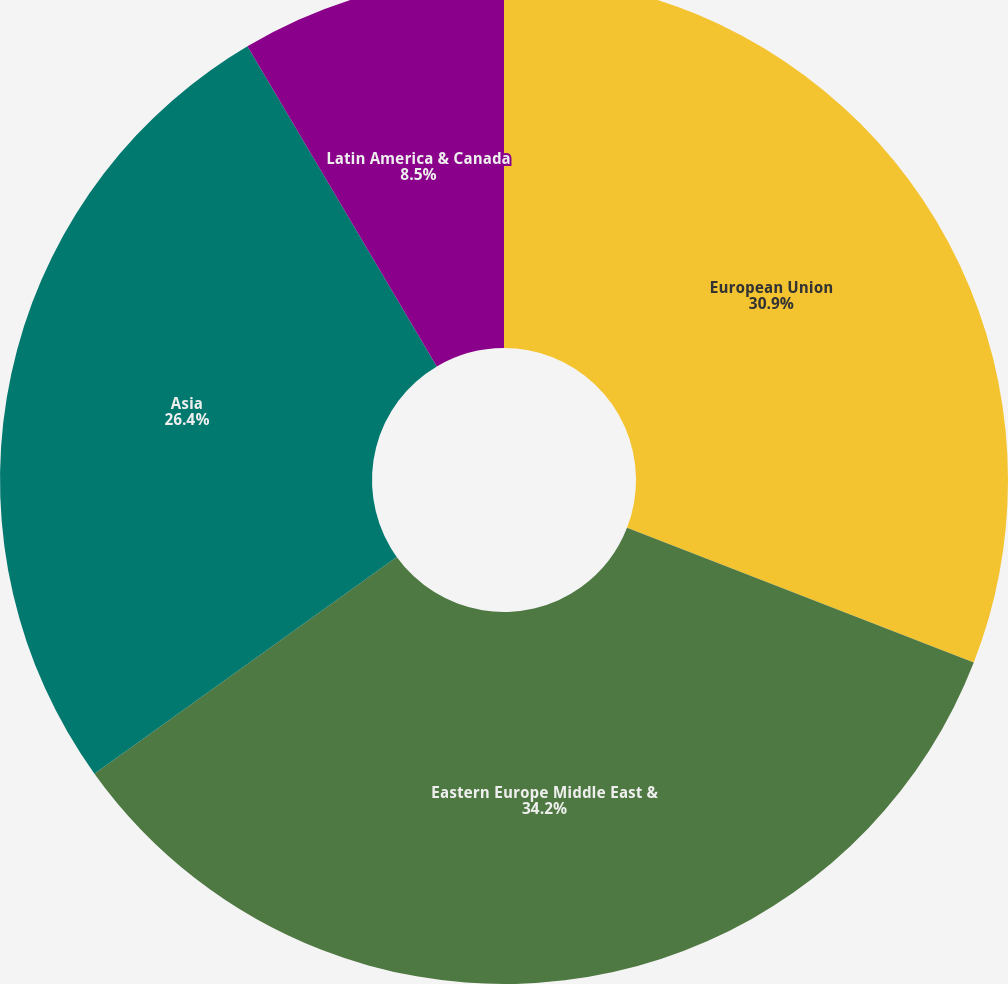Convert chart to OTSL. <chart><loc_0><loc_0><loc_500><loc_500><pie_chart><fcel>European Union<fcel>Eastern Europe Middle East &<fcel>Asia<fcel>Latin America & Canada<nl><fcel>30.9%<fcel>34.2%<fcel>26.4%<fcel>8.5%<nl></chart> 